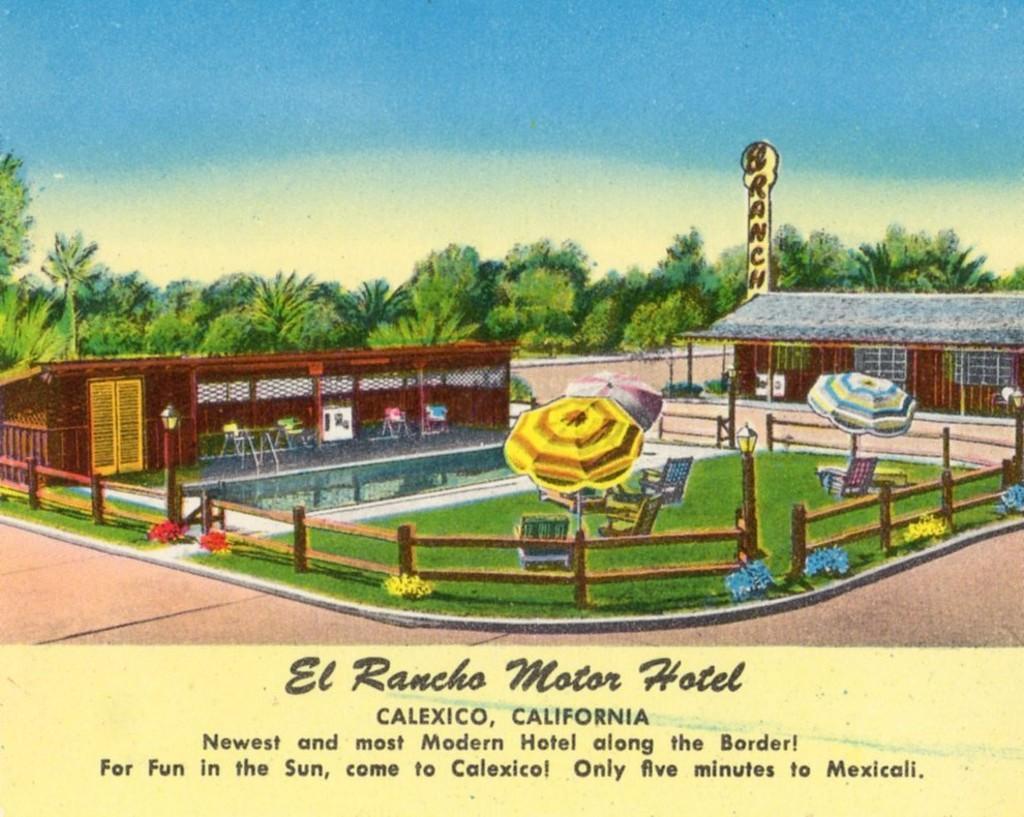Can you describe this image briefly? This image contains a painting. In it there are two houses. There are few chairs under the roof. Few chairs and umbrellas are on the grassland which is surrounded by fence having a lamp on it. Middle of image there are few trees. Top of image there is sky. Bottom of image there is some text. 